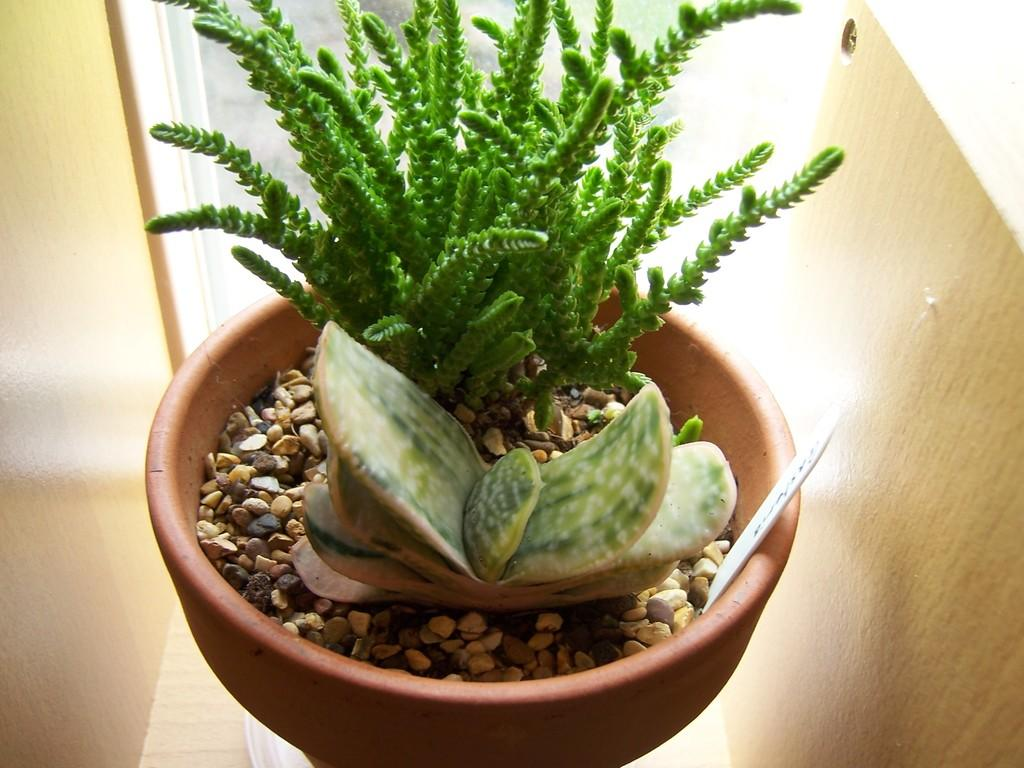What object is present in the image that is typically used for holding plants? There is a plant pot in the image. What type of material can be seen in the image, besides the plant pot? There are stones in the image. What structure is visible in the background of the image? There is a wall in the image. What type of digestion can be observed in the image? There is no digestion present in the image; it features a plant pot, stones, and a wall. What type of fang can be seen in the image? There are no fangs present in the image. 